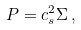<formula> <loc_0><loc_0><loc_500><loc_500>P = c _ { s } ^ { 2 } \Sigma \, ,</formula> 